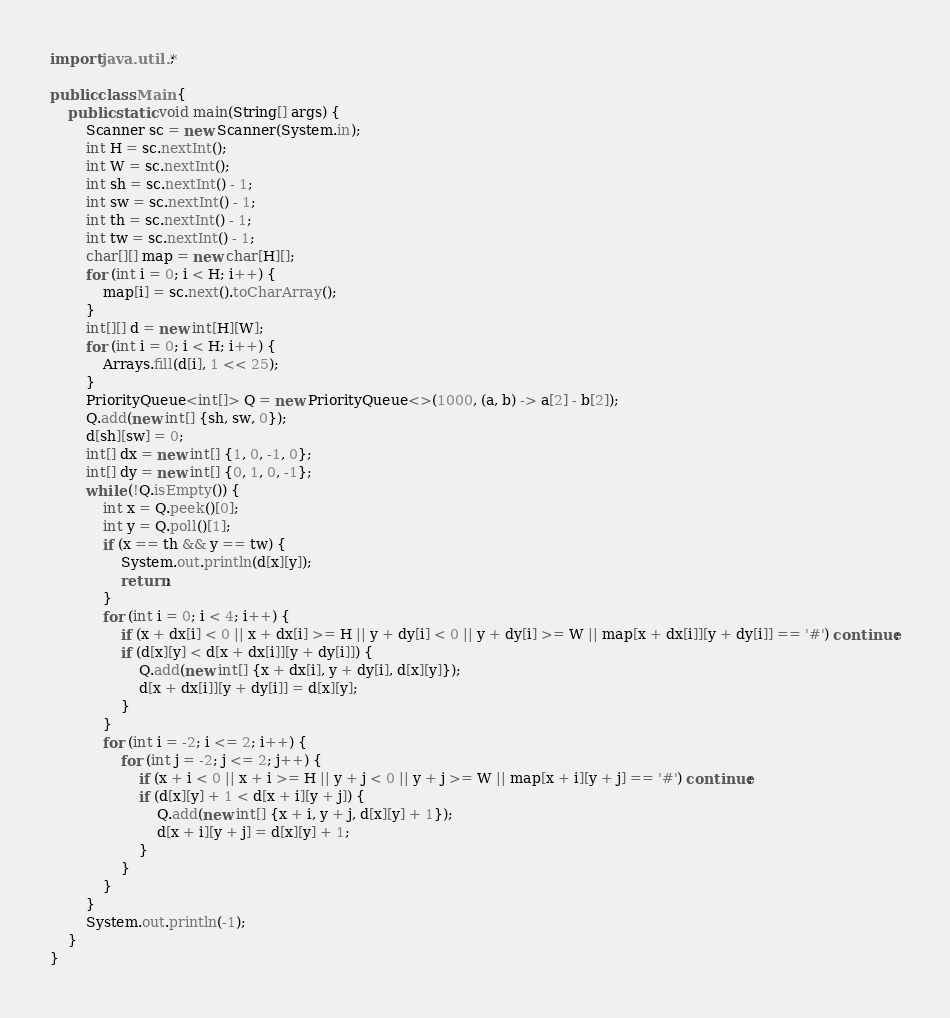Convert code to text. <code><loc_0><loc_0><loc_500><loc_500><_Java_>import java.util.*;

public class Main {
	public static void main(String[] args) {
		Scanner sc = new Scanner(System.in);
		int H = sc.nextInt();
		int W = sc.nextInt();
		int sh = sc.nextInt() - 1;
		int sw = sc.nextInt() - 1;
		int th = sc.nextInt() - 1;
		int tw = sc.nextInt() - 1;
		char[][] map = new char[H][];
		for (int i = 0; i < H; i++) {
			map[i] = sc.next().toCharArray();
		}
		int[][] d = new int[H][W];
		for (int i = 0; i < H; i++) {
			Arrays.fill(d[i], 1 << 25);
		}
		PriorityQueue<int[]> Q = new PriorityQueue<>(1000, (a, b) -> a[2] - b[2]);
		Q.add(new int[] {sh, sw, 0});
		d[sh][sw] = 0;
		int[] dx = new int[] {1, 0, -1, 0};
		int[] dy = new int[] {0, 1, 0, -1};
		while (!Q.isEmpty()) {
			int x = Q.peek()[0];
			int y = Q.poll()[1];
			if (x == th && y == tw) {
				System.out.println(d[x][y]);
				return;
			}
			for (int i = 0; i < 4; i++) {
				if (x + dx[i] < 0 || x + dx[i] >= H || y + dy[i] < 0 || y + dy[i] >= W || map[x + dx[i]][y + dy[i]] == '#') continue;
				if (d[x][y] < d[x + dx[i]][y + dy[i]]) {
					Q.add(new int[] {x + dx[i], y + dy[i], d[x][y]});
					d[x + dx[i]][y + dy[i]] = d[x][y];
				}
			}
			for (int i = -2; i <= 2; i++) {
				for (int j = -2; j <= 2; j++) {
					if (x + i < 0 || x + i >= H || y + j < 0 || y + j >= W || map[x + i][y + j] == '#') continue;
					if (d[x][y] + 1 < d[x + i][y + j]) {
						Q.add(new int[] {x + i, y + j, d[x][y] + 1});
						d[x + i][y + j] = d[x][y] + 1;
					}
				}
			}
		}
		System.out.println(-1);
	}
}</code> 